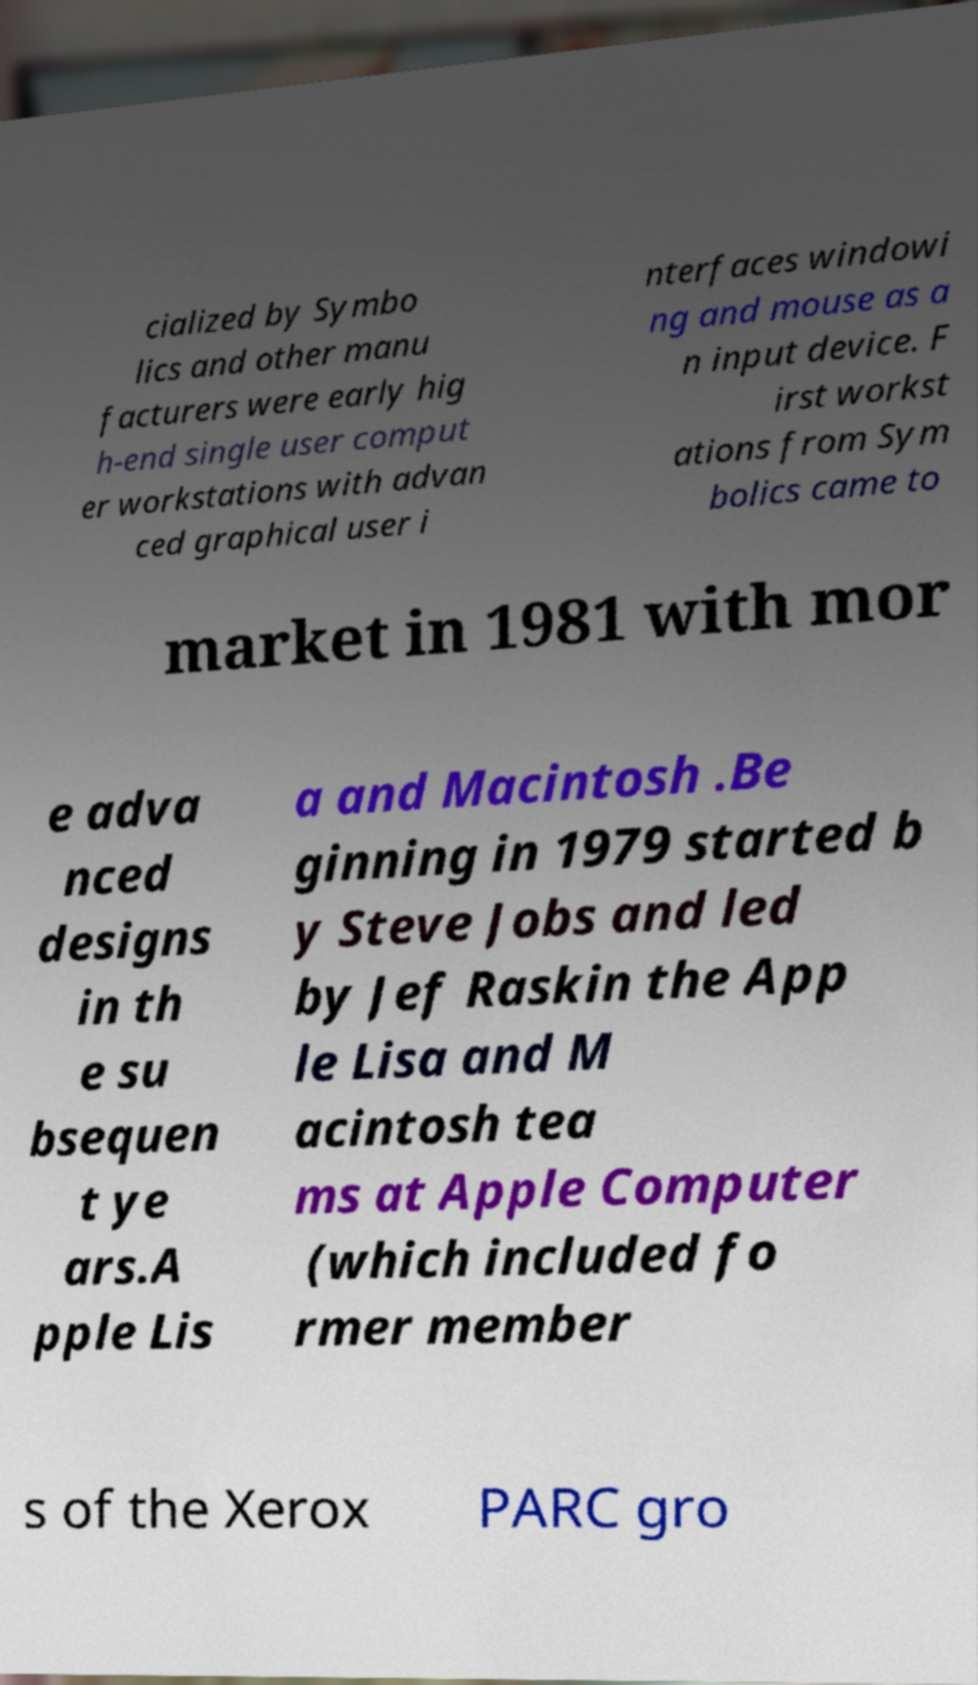Please identify and transcribe the text found in this image. cialized by Symbo lics and other manu facturers were early hig h-end single user comput er workstations with advan ced graphical user i nterfaces windowi ng and mouse as a n input device. F irst workst ations from Sym bolics came to market in 1981 with mor e adva nced designs in th e su bsequen t ye ars.A pple Lis a and Macintosh .Be ginning in 1979 started b y Steve Jobs and led by Jef Raskin the App le Lisa and M acintosh tea ms at Apple Computer (which included fo rmer member s of the Xerox PARC gro 